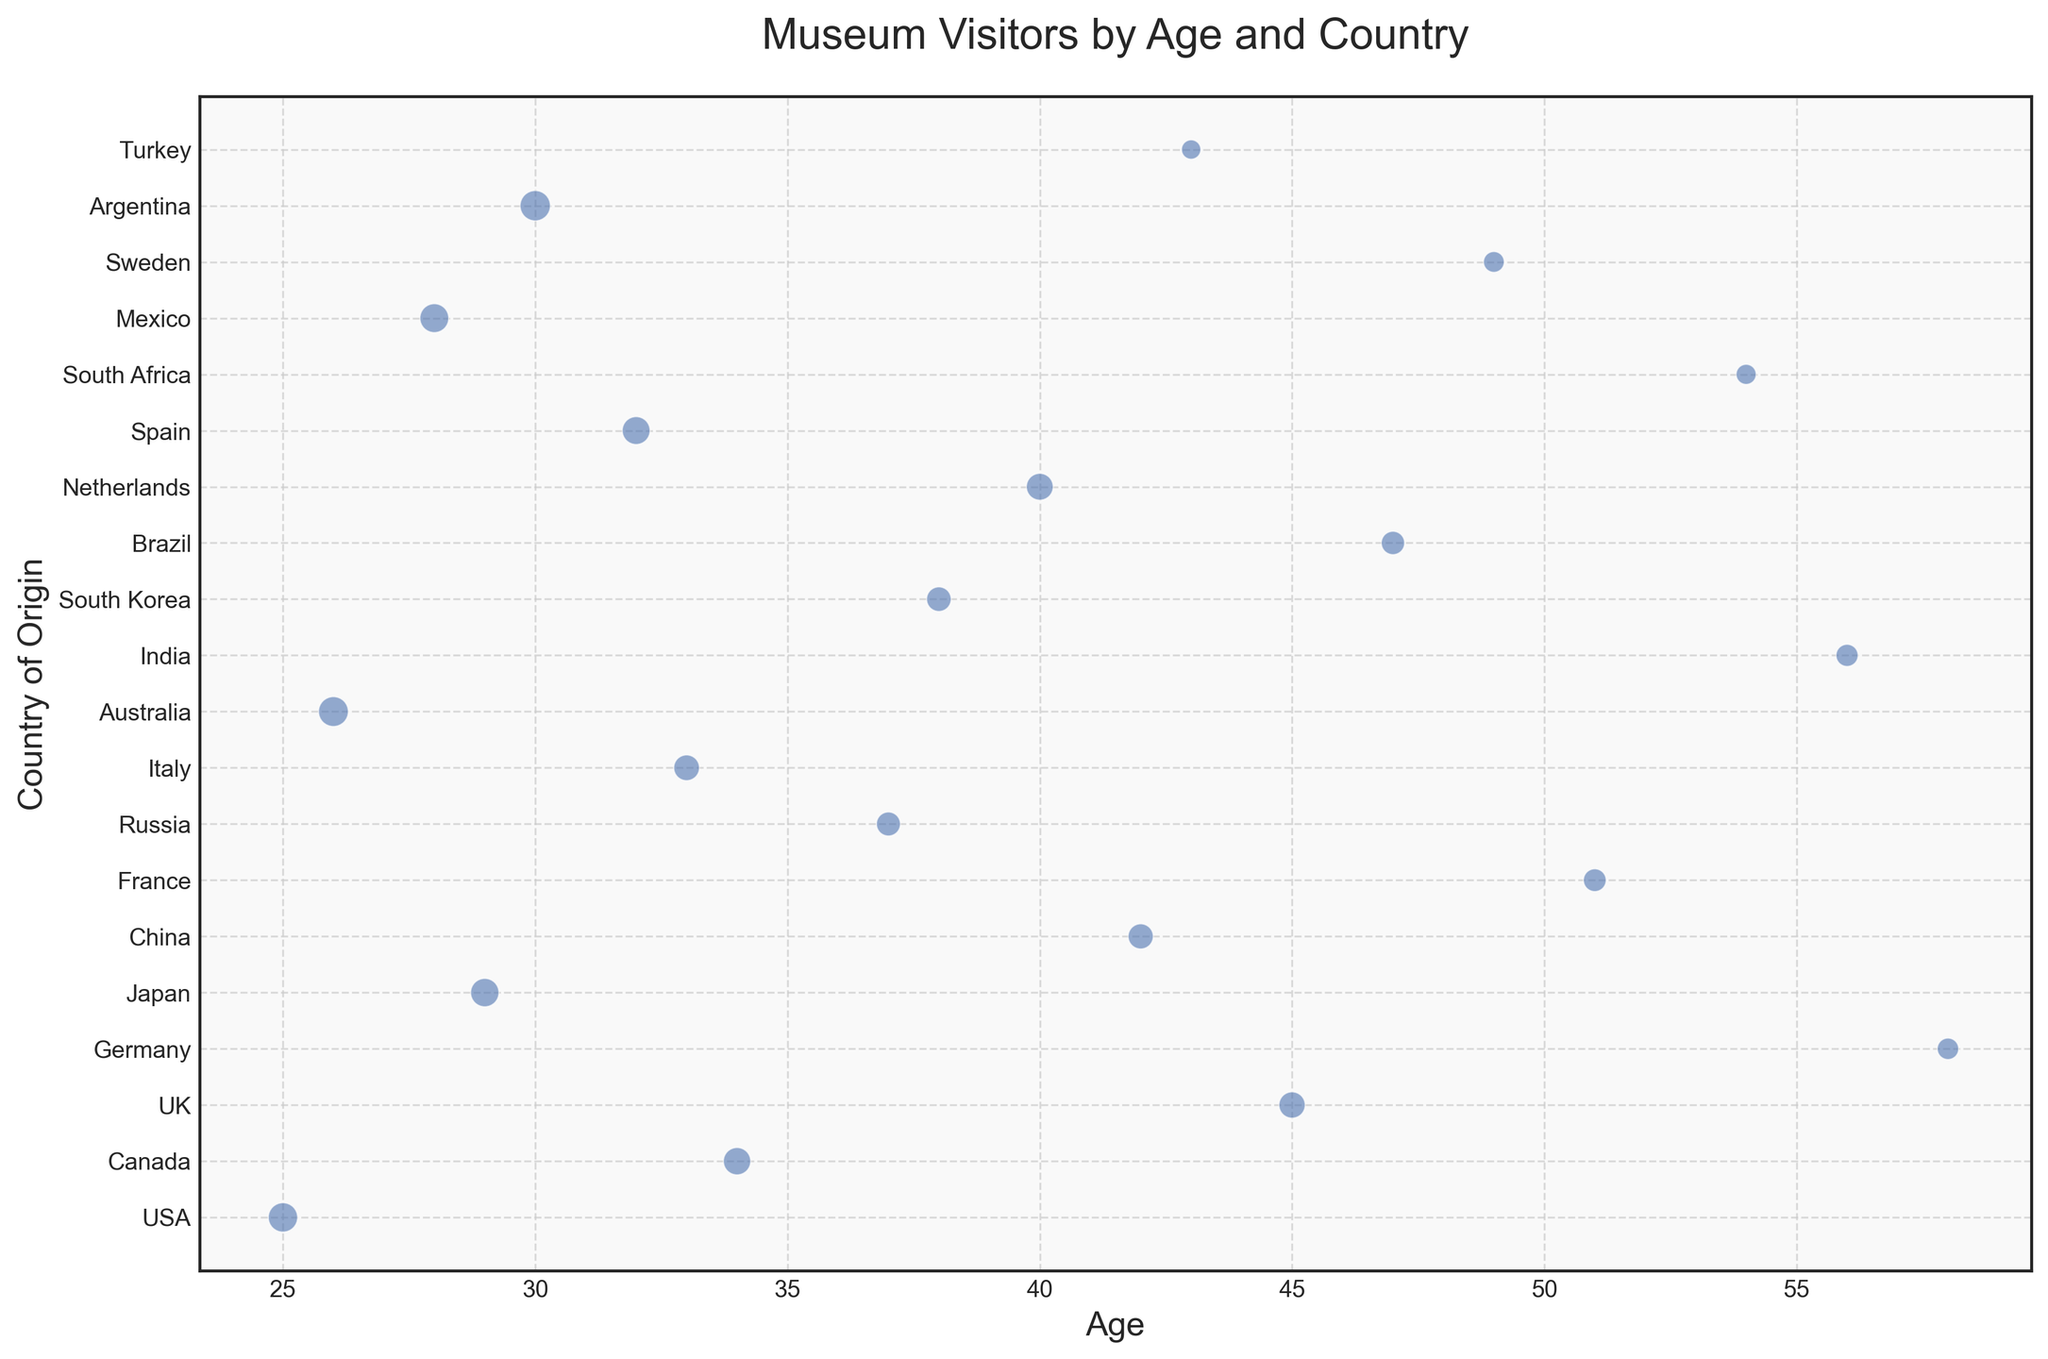What is the age group with the most visitors and from which country do they come? From the scatter plot, identify the data point with the largest bubble size representing the number of visitors. The 30-year-old age group has the largest bubble size, and they are from Argentina.
Answer: 30, Argentina Which two age groups have visitors from countries with similar visitor counts? Scan the plot to find bubbles that look similar in size. The age groups 29 from Japan and 32 from Spain both have bubbles of similar size (visitors: 140 for Japan, 135 for Spain).
Answer: 29, 32 What is the total number of visitors from all age groups under 30? From the plot, note the visitor counts for ages under 30: 25 (150 visitors), 26 (155 visitors), 28 (145 visitors), and 29 (140 visitors). Summing these: 150+155+145+140 = 590.
Answer: 590 Which country's visitors have a median age closest to 40? First, list the ages of visitors from each country. Then identify the country whose visitors' median age is closest to 40; for instance, if two visitors are from 38 and 42, the median is close to 40. For China, the single data point age 42 is the closest to 40.
Answer: China How do the visitor counts from the USA and Canada compare? Locate the bubbles for the USA (25 years, 150 visitors) and Canada (34 years, 130 visitors). Compare the sizes directly. The USA has more visitors than Canada.
Answer: USA has more visitors Which age group and country combination has the fewest visitors? Identify the smallest bubble in the scatter plot. At age 43, Turkey has the smallest number of visitors, at 65.
Answer: 43, Turkey What is the visitor difference between the age group from South Africa and Japan? Note the visitor counts for these countries (54 years, South Africa: 70 visitors; 29 years, Japan: 140 visitors). The difference is 140 - 70 = 70.
Answer: 70 How many countries have visitors aged between 40 and 50? From the plot, count the data points within the age range 40 to 50: UK (45), China (42), Brazil (47), Netherlands (40), Turkey (43). Total is 5 countries.
Answer: 5 What is the combined visitor count for visitors aged 45 or older? Sum up visitor counts for ages 45 and above: 45 (UK: 120), 47 (Brazil: 95), 49 (Sweden: 75), 51 (France: 90), 54 (South Africa: 70), 56 (India: 85), 58 (Germany: 80). Total is 120 + 95 + 75 + 90 + 70 + 85 + 80 = 615.
Answer: 615 